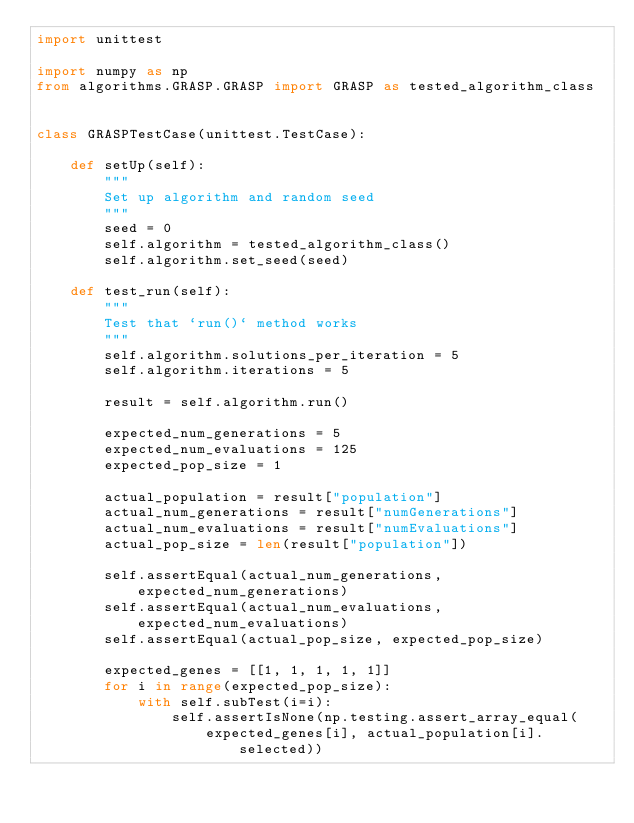Convert code to text. <code><loc_0><loc_0><loc_500><loc_500><_Python_>import unittest

import numpy as np
from algorithms.GRASP.GRASP import GRASP as tested_algorithm_class


class GRASPTestCase(unittest.TestCase):

    def setUp(self):
        """  
        Set up algorithm and random seed
        """
        seed = 0
        self.algorithm = tested_algorithm_class()
        self.algorithm.set_seed(seed)

    def test_run(self):
        """  
        Test that `run()` method works
        """
        self.algorithm.solutions_per_iteration = 5
        self.algorithm.iterations = 5

        result = self.algorithm.run()

        expected_num_generations = 5
        expected_num_evaluations = 125
        expected_pop_size = 1

        actual_population = result["population"]
        actual_num_generations = result["numGenerations"]
        actual_num_evaluations = result["numEvaluations"]
        actual_pop_size = len(result["population"])

        self.assertEqual(actual_num_generations, expected_num_generations)
        self.assertEqual(actual_num_evaluations, expected_num_evaluations)
        self.assertEqual(actual_pop_size, expected_pop_size)

        expected_genes = [[1, 1, 1, 1, 1]]
        for i in range(expected_pop_size):
            with self.subTest(i=i):
                self.assertIsNone(np.testing.assert_array_equal(
                    expected_genes[i], actual_population[i].selected))
</code> 